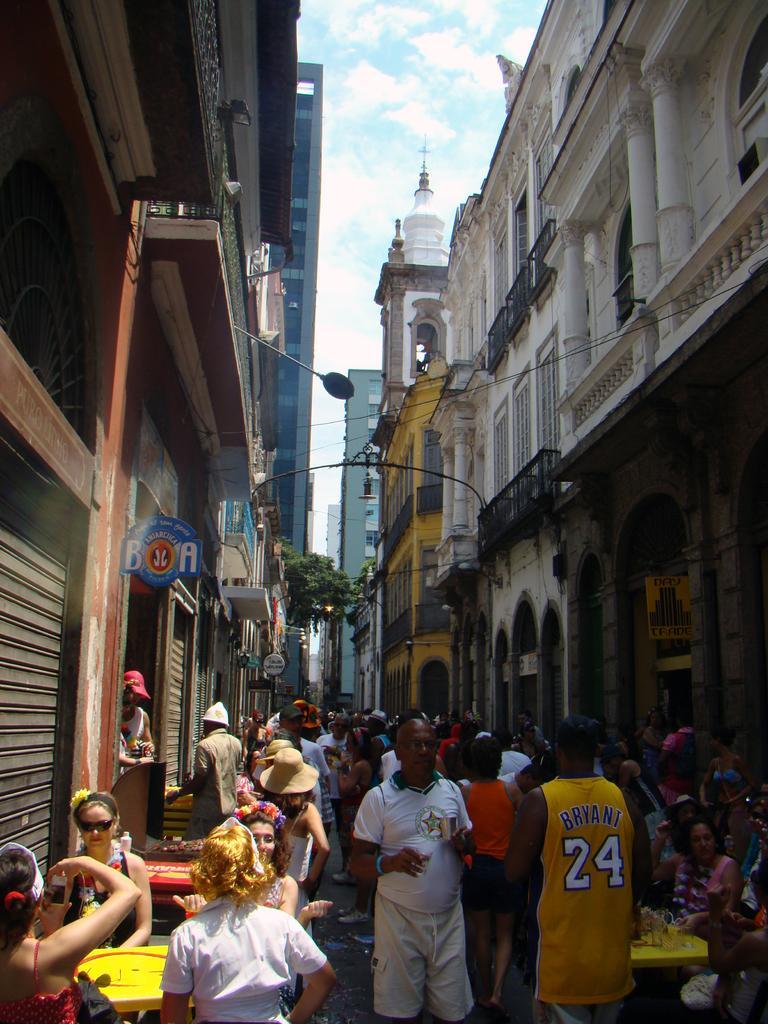Describe this image in one or two sentences. In the picture I can see a group of people among them some are sitting and some are walking on the ground. In the background I can see buildings, wires, the sky and some other things. 